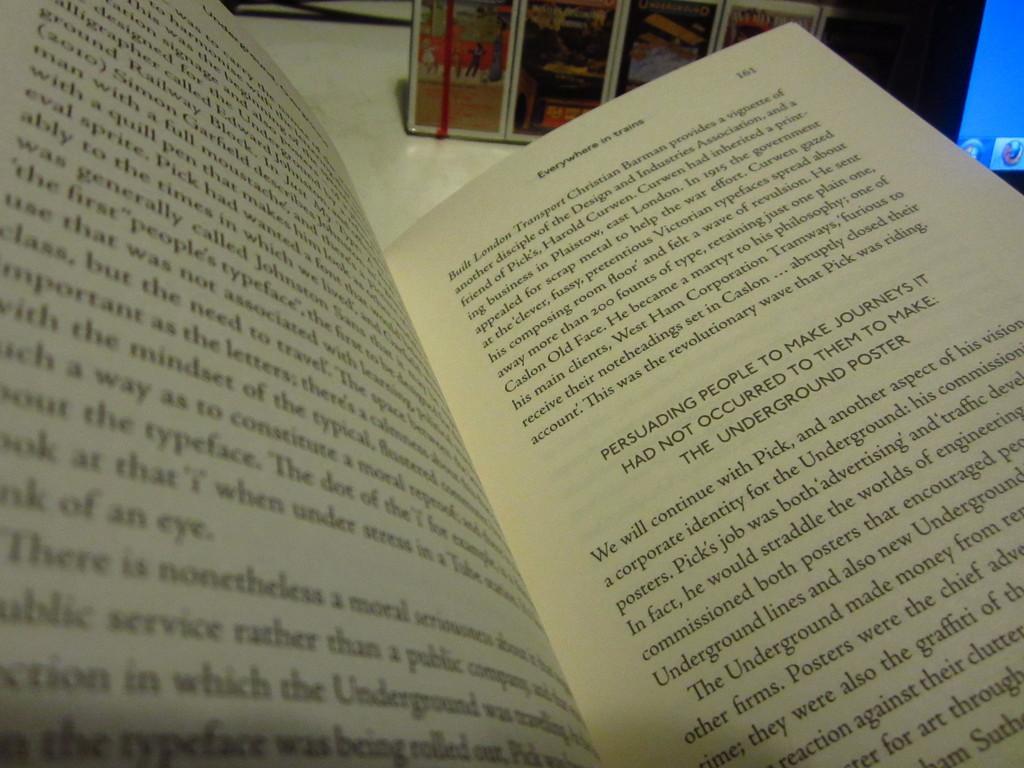<image>
Share a concise interpretation of the image provided. Open book named Everywhere in trains on page 161. 